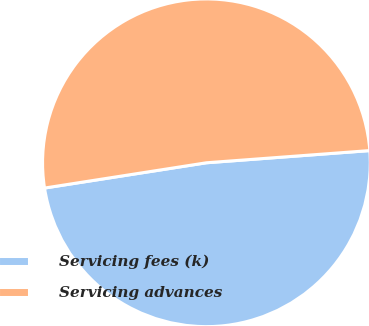Convert chart to OTSL. <chart><loc_0><loc_0><loc_500><loc_500><pie_chart><fcel>Servicing fees (k)<fcel>Servicing advances<nl><fcel>48.72%<fcel>51.28%<nl></chart> 